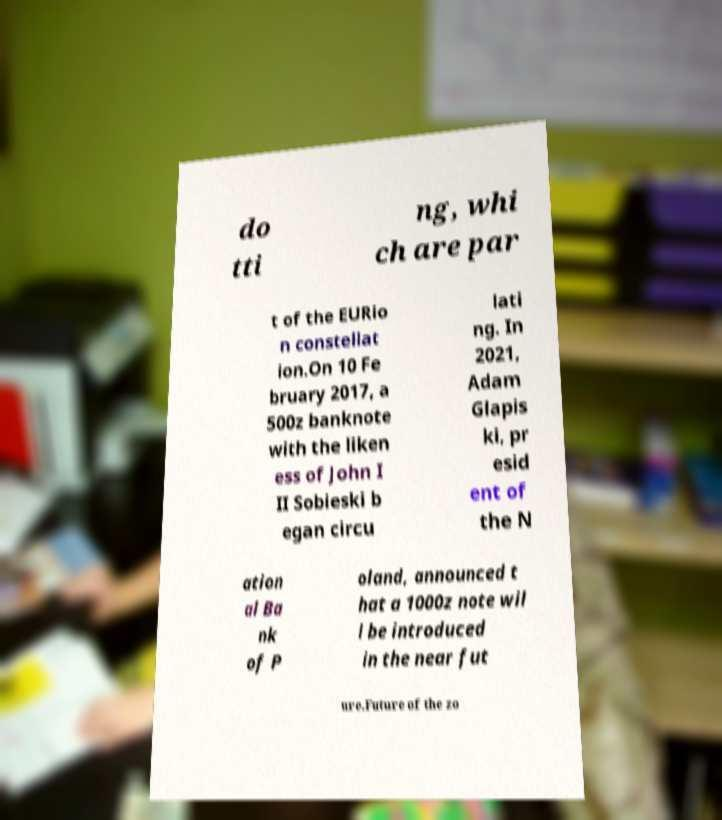Can you accurately transcribe the text from the provided image for me? do tti ng, whi ch are par t of the EURio n constellat ion.On 10 Fe bruary 2017, a 500z banknote with the liken ess of John I II Sobieski b egan circu lati ng. In 2021, Adam Glapis ki, pr esid ent of the N ation al Ba nk of P oland, announced t hat a 1000z note wil l be introduced in the near fut ure.Future of the zo 